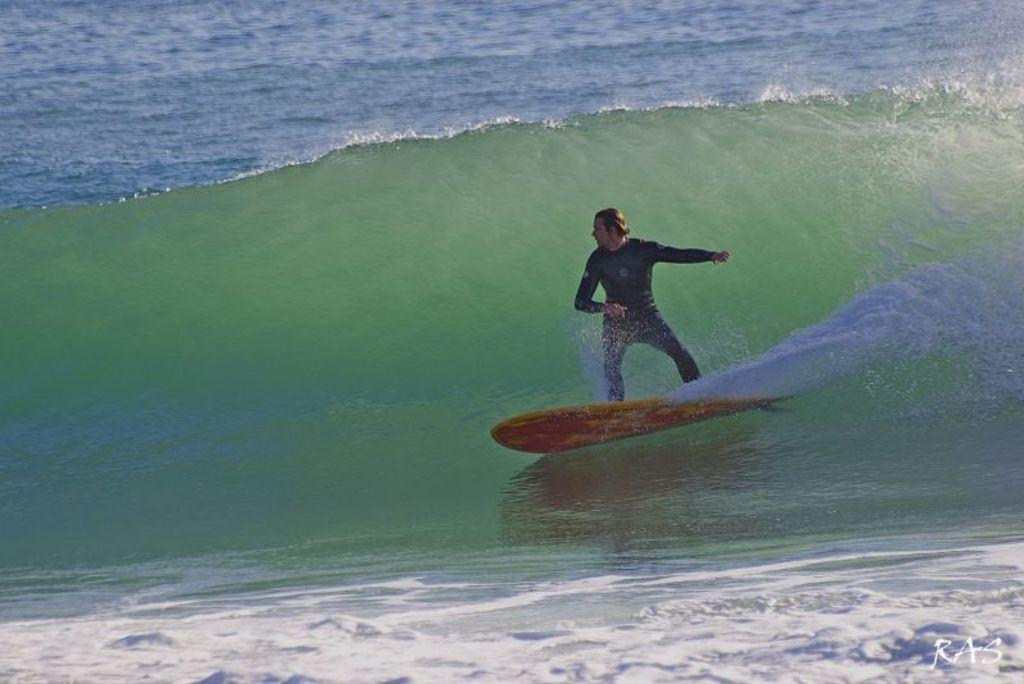Could you give a brief overview of what you see in this image? In the foreground I can see a person is skiing in the ocean. This image is taken may be in the ocean during a day. 